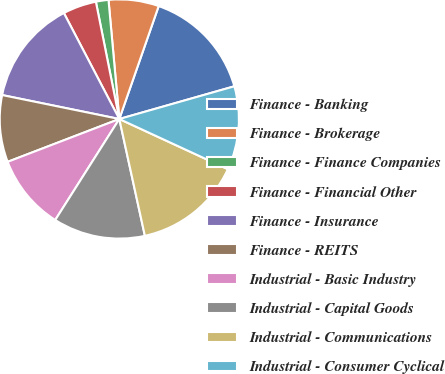Convert chart to OTSL. <chart><loc_0><loc_0><loc_500><loc_500><pie_chart><fcel>Finance - Banking<fcel>Finance - Brokerage<fcel>Finance - Finance Companies<fcel>Finance - Financial Other<fcel>Finance - Insurance<fcel>Finance - REITS<fcel>Industrial - Basic Industry<fcel>Industrial - Capital Goods<fcel>Industrial - Communications<fcel>Industrial - Consumer Cyclical<nl><fcel>15.25%<fcel>6.78%<fcel>1.7%<fcel>4.53%<fcel>14.12%<fcel>9.04%<fcel>10.17%<fcel>12.43%<fcel>14.68%<fcel>11.3%<nl></chart> 